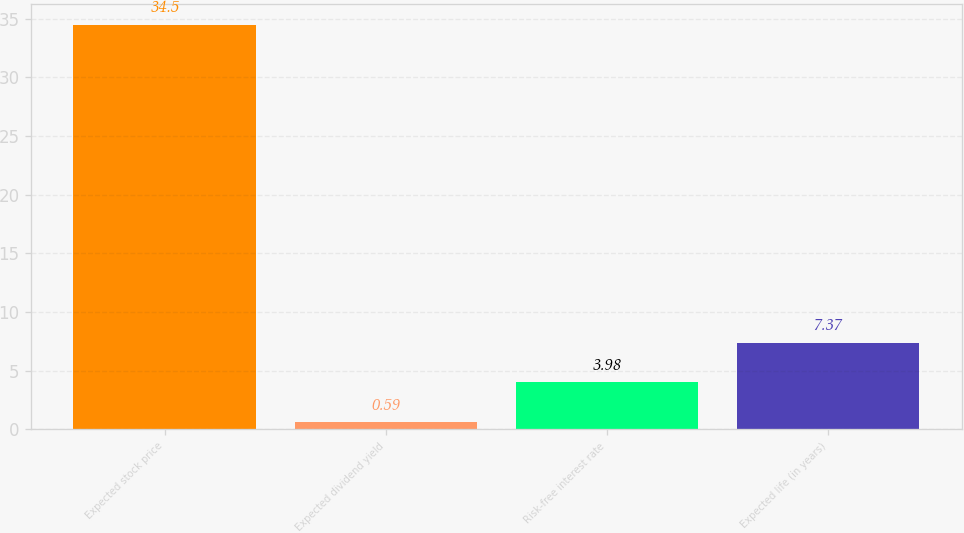<chart> <loc_0><loc_0><loc_500><loc_500><bar_chart><fcel>Expected stock price<fcel>Expected dividend yield<fcel>Risk-free interest rate<fcel>Expected life (in years)<nl><fcel>34.5<fcel>0.59<fcel>3.98<fcel>7.37<nl></chart> 